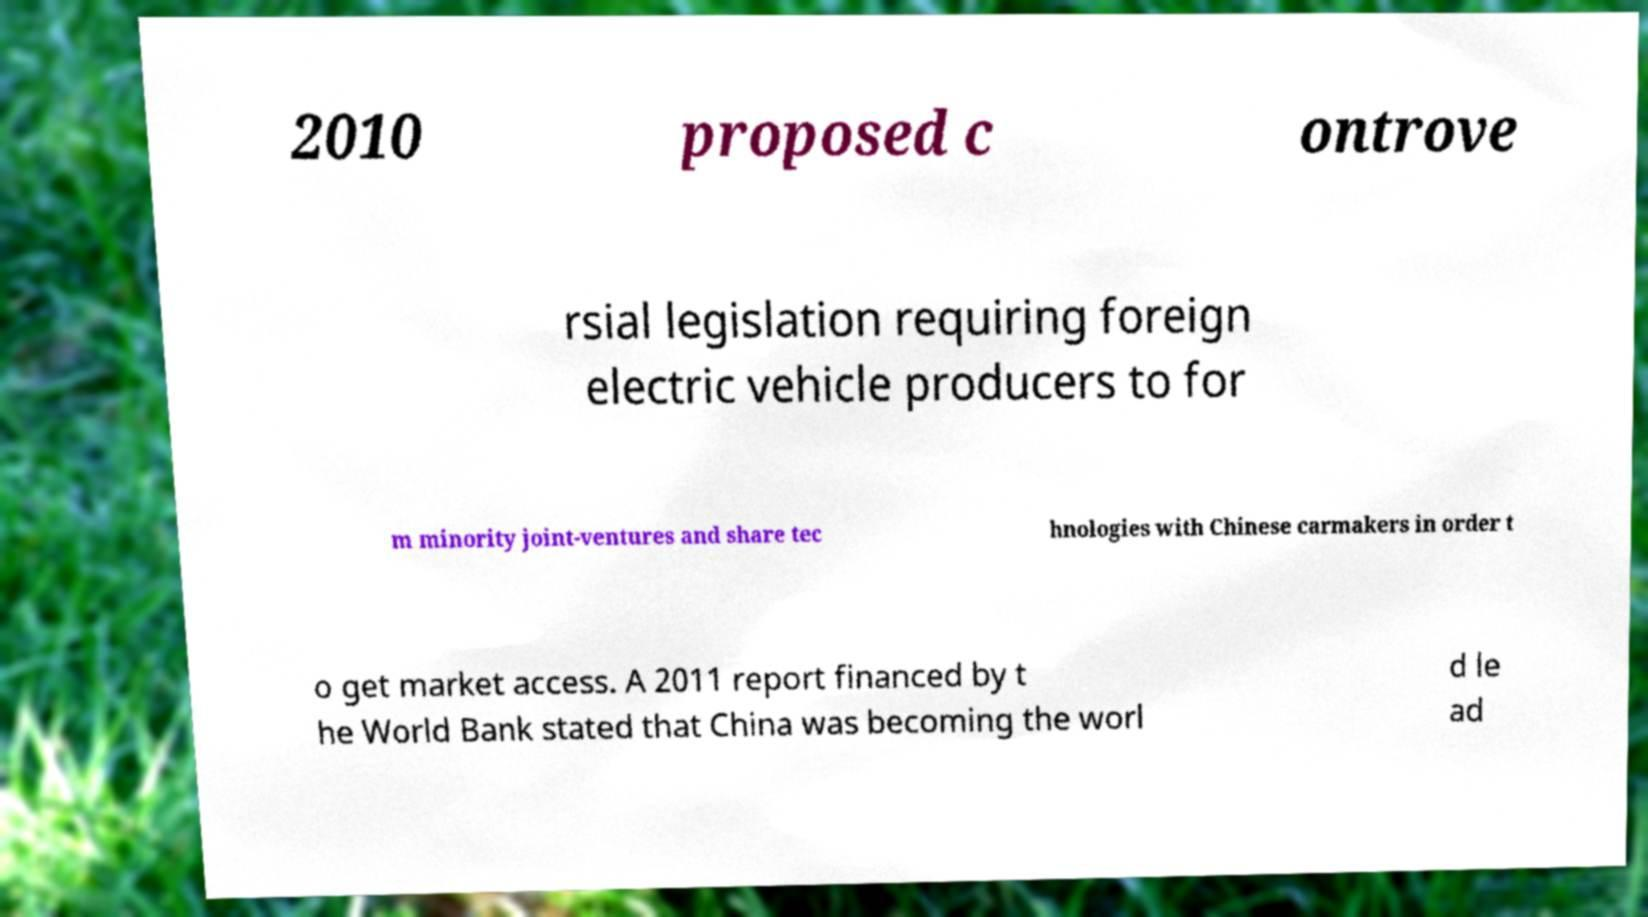What messages or text are displayed in this image? I need them in a readable, typed format. 2010 proposed c ontrove rsial legislation requiring foreign electric vehicle producers to for m minority joint-ventures and share tec hnologies with Chinese carmakers in order t o get market access. A 2011 report financed by t he World Bank stated that China was becoming the worl d le ad 